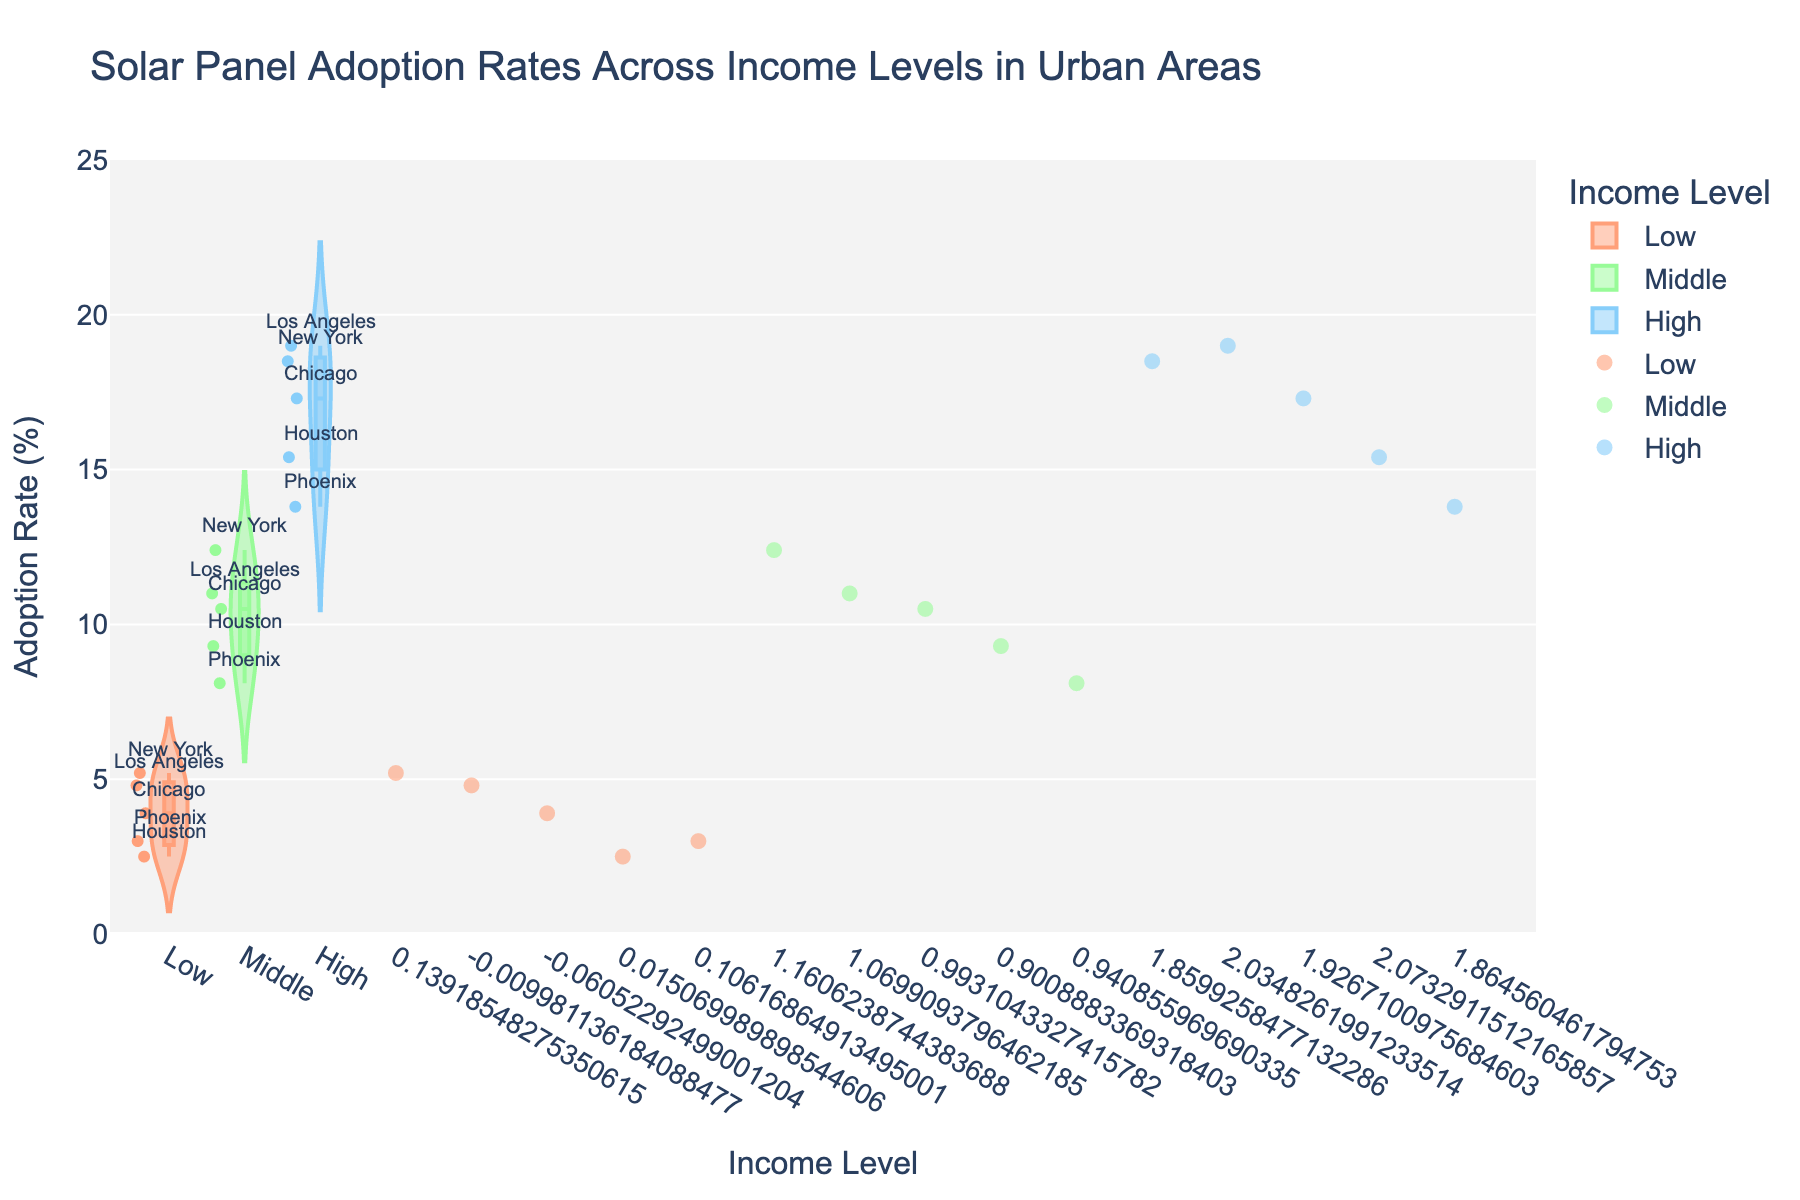What is the title of the figure? The title is typically displayed at the top of the figure. In this figure, the title is easy to identify.
Answer: Solar Panel Adoption Rates Across Income Levels in Urban Areas How many income levels are represented in the figure? The number of income levels can be seen by counting the distinct categories on the x-axis.
Answer: Three Which income level has the highest adoption rate of solar panels? By comparing the highest points in each income level's distribution, we can identify the one with the highest value.
Answer: High What is the adoption rate range for the middle-income level? By observing the spread of the violin plot for the middle-income level, we can determine its range.
Answer: 8.1% to 12.4% Which city has the lowest adoption rate of solar panels in the low-income level? The lowest point in the jittered points for the low-income group will indicate this city.
Answer: Houston Compare the adoption rate ranges between the low-income and high-income levels. Look at the spread (minimum to maximum values) of the violin plots for both low and high-income levels to compare.
Answer: Low: 2.5% to 5.2%, High: 13.8% to 19.0% What is the median adoption rate for the low-income level? The median can typically be identified by looking at the position of the box within the violin plot for the low-income group.
Answer: 3.9% Which city in the middle-income level has the second highest adoption rate of solar panels? Within the middle-income plot, identify the city corresponding to the second highest jittered point.
Answer: Los Angeles Rank the cities in the high-income level based on their adoption rates of solar panels. Sort the cities in the high-income level by their adoption rates from highest to lowest.
Answer: Los Angeles, New York, Chicago, Houston, Phoenix By how much does the adoption rate vary between the highest and lowest income levels? Calculate the difference between the highest value in the high-income level and the highest value in the low-income level.
Answer: 19.0% - 5.2% = 13.8% 